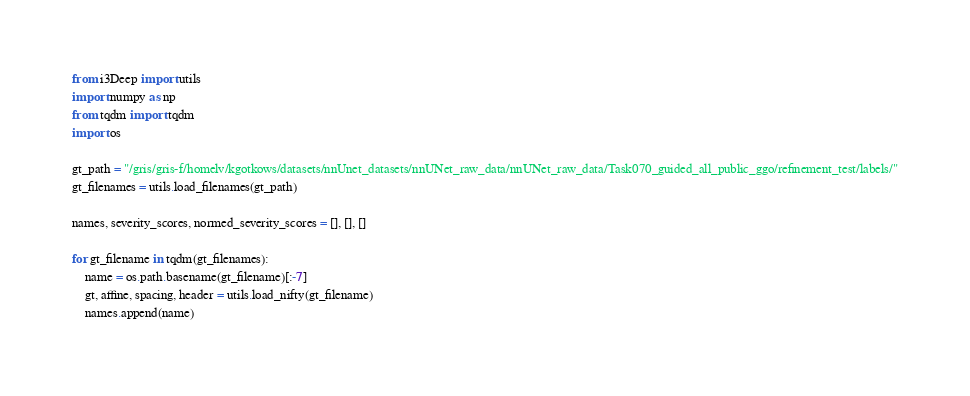Convert code to text. <code><loc_0><loc_0><loc_500><loc_500><_Python_>from i3Deep import utils
import numpy as np
from tqdm import tqdm
import os

gt_path = "/gris/gris-f/homelv/kgotkows/datasets/nnUnet_datasets/nnUNet_raw_data/nnUNet_raw_data/Task070_guided_all_public_ggo/refinement_test/labels/"
gt_filenames = utils.load_filenames(gt_path)

names, severity_scores, normed_severity_scores = [], [], []

for gt_filename in tqdm(gt_filenames):
    name = os.path.basename(gt_filename)[:-7]
    gt, affine, spacing, header = utils.load_nifty(gt_filename)
    names.append(name)</code> 